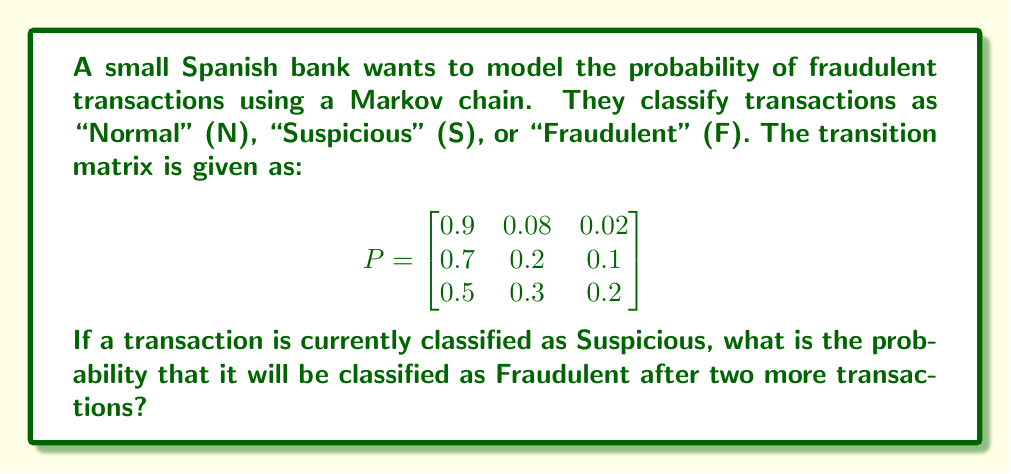Show me your answer to this math problem. To solve this problem, we'll use the properties of Markov chains:

1. Identify the initial state: The transaction is currently Suspicious (S).

2. Calculate $P^2$ (the transition matrix after two steps):
   $$P^2 = P \times P = \begin{bmatrix}
   0.9 & 0.08 & 0.02 \\
   0.7 & 0.2 & 0.1 \\
   0.5 & 0.3 & 0.2
   \end{bmatrix} \times \begin{bmatrix}
   0.9 & 0.08 & 0.02 \\
   0.7 & 0.2 & 0.1 \\
   0.5 & 0.3 & 0.2
   \end{bmatrix}$$

3. Perform matrix multiplication:
   $$P^2 = \begin{bmatrix}
   0.85 & 0.11 & 0.04 \\
   0.76 & 0.17 & 0.07 \\
   0.68 & 0.22 & 0.10
   \end{bmatrix}$$

4. The initial state vector for Suspicious is $[0 \quad 1 \quad 0]$.

5. Multiply the initial state vector by $P^2$:
   $$[0 \quad 1 \quad 0] \times \begin{bmatrix}
   0.85 & 0.11 & 0.04 \\
   0.76 & 0.17 & 0.07 \\
   0.68 & 0.22 & 0.10
   \end{bmatrix} = [0.76 \quad 0.17 \quad 0.07]$$

6. The probability of being in the Fraudulent state after two transactions is the third element of the resulting vector: 0.07.
Answer: 0.07 